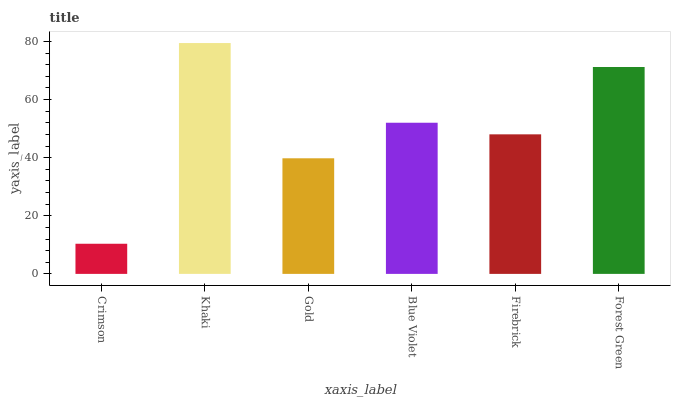Is Crimson the minimum?
Answer yes or no. Yes. Is Khaki the maximum?
Answer yes or no. Yes. Is Gold the minimum?
Answer yes or no. No. Is Gold the maximum?
Answer yes or no. No. Is Khaki greater than Gold?
Answer yes or no. Yes. Is Gold less than Khaki?
Answer yes or no. Yes. Is Gold greater than Khaki?
Answer yes or no. No. Is Khaki less than Gold?
Answer yes or no. No. Is Blue Violet the high median?
Answer yes or no. Yes. Is Firebrick the low median?
Answer yes or no. Yes. Is Khaki the high median?
Answer yes or no. No. Is Forest Green the low median?
Answer yes or no. No. 